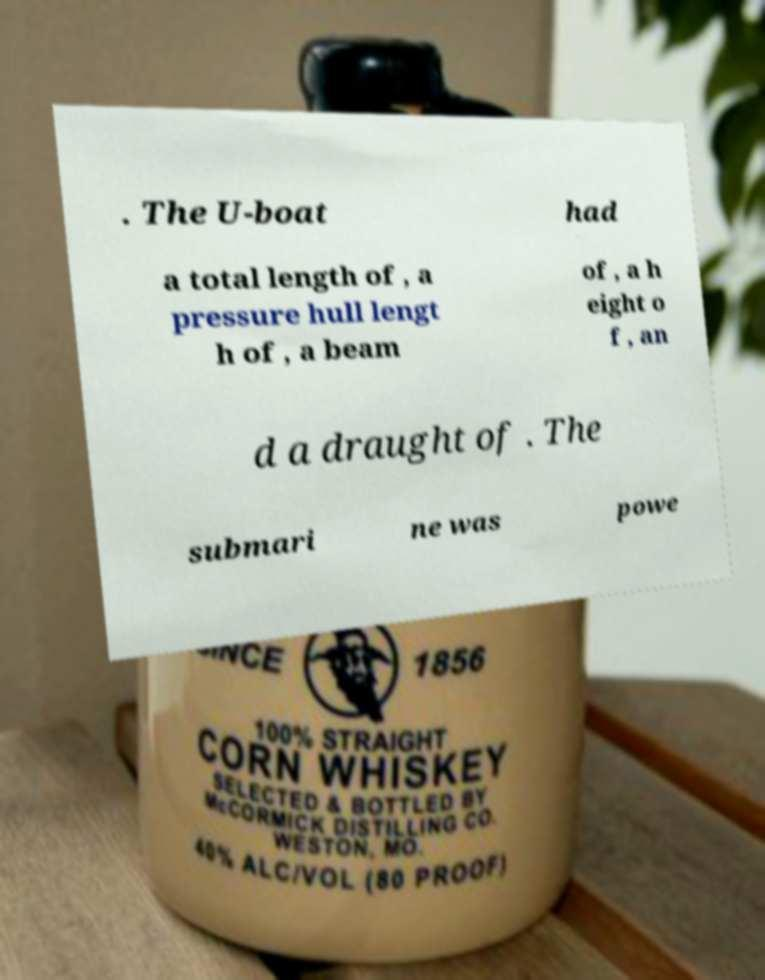I need the written content from this picture converted into text. Can you do that? . The U-boat had a total length of , a pressure hull lengt h of , a beam of , a h eight o f , an d a draught of . The submari ne was powe 